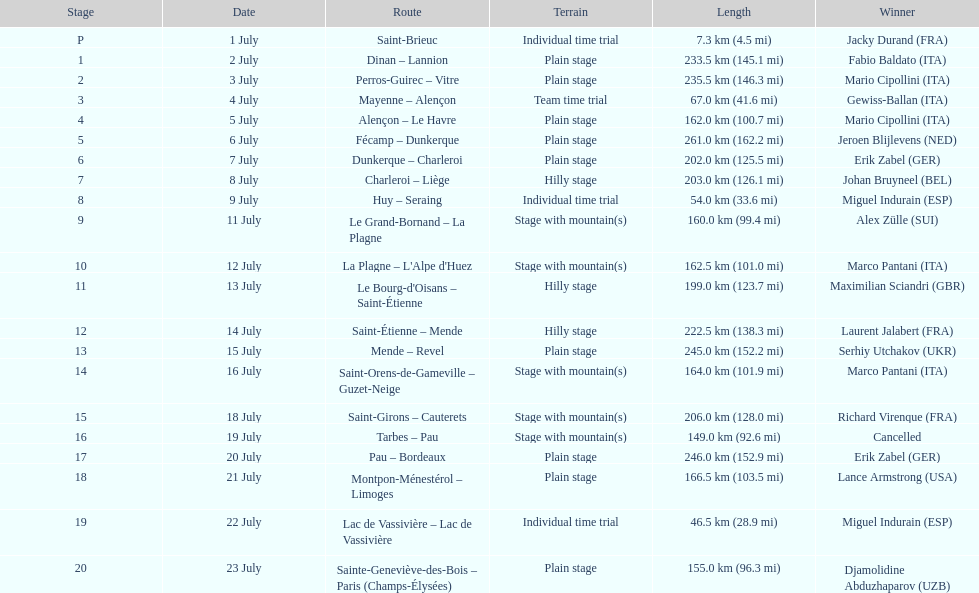How many successive km were raced on july 8th? 203.0 km (126.1 mi). 